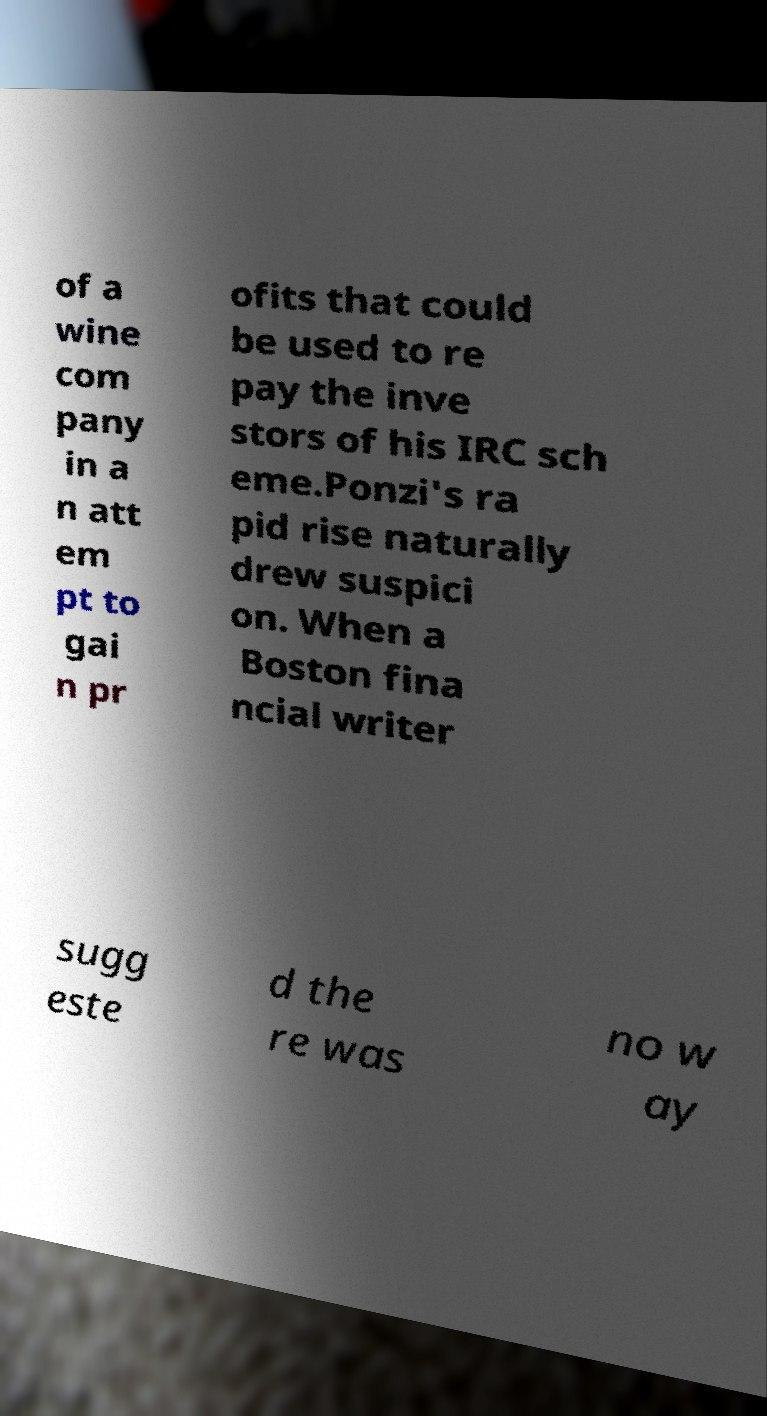Please identify and transcribe the text found in this image. of a wine com pany in a n att em pt to gai n pr ofits that could be used to re pay the inve stors of his IRC sch eme.Ponzi's ra pid rise naturally drew suspici on. When a Boston fina ncial writer sugg este d the re was no w ay 